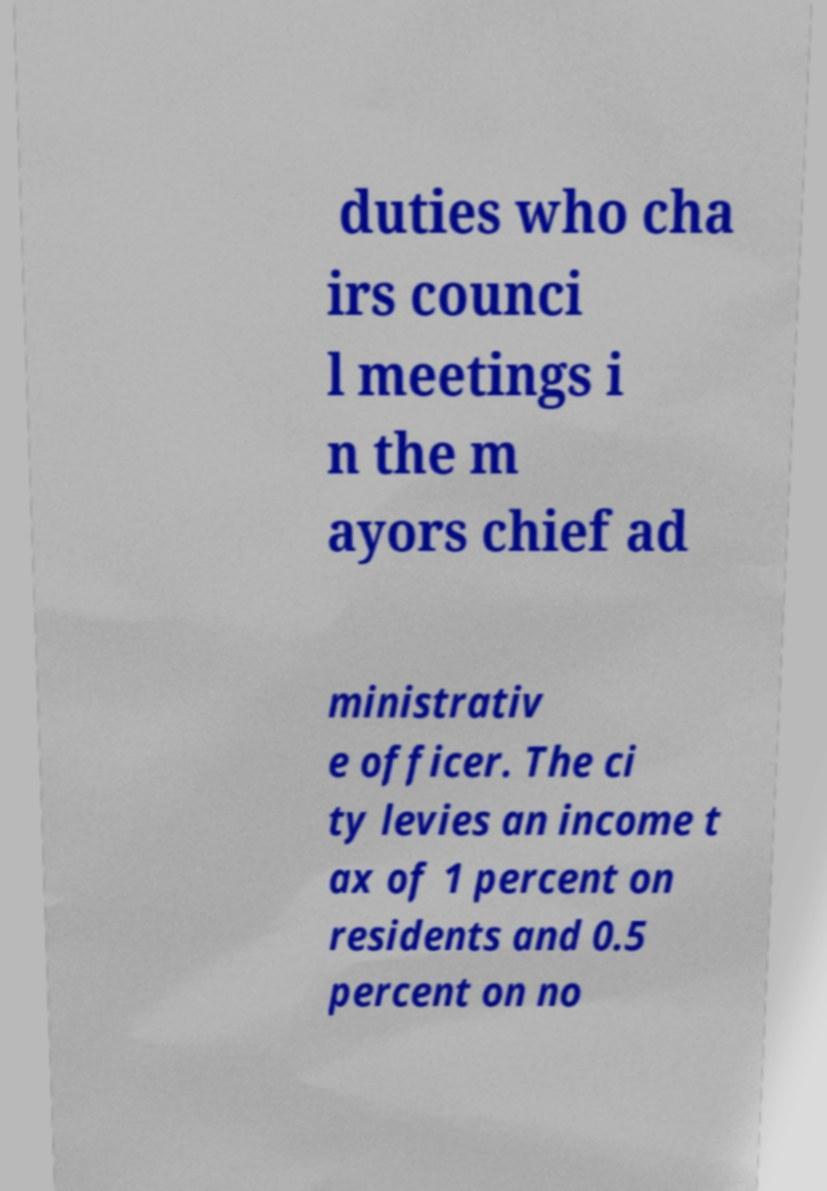Can you accurately transcribe the text from the provided image for me? duties who cha irs counci l meetings i n the m ayors chief ad ministrativ e officer. The ci ty levies an income t ax of 1 percent on residents and 0.5 percent on no 